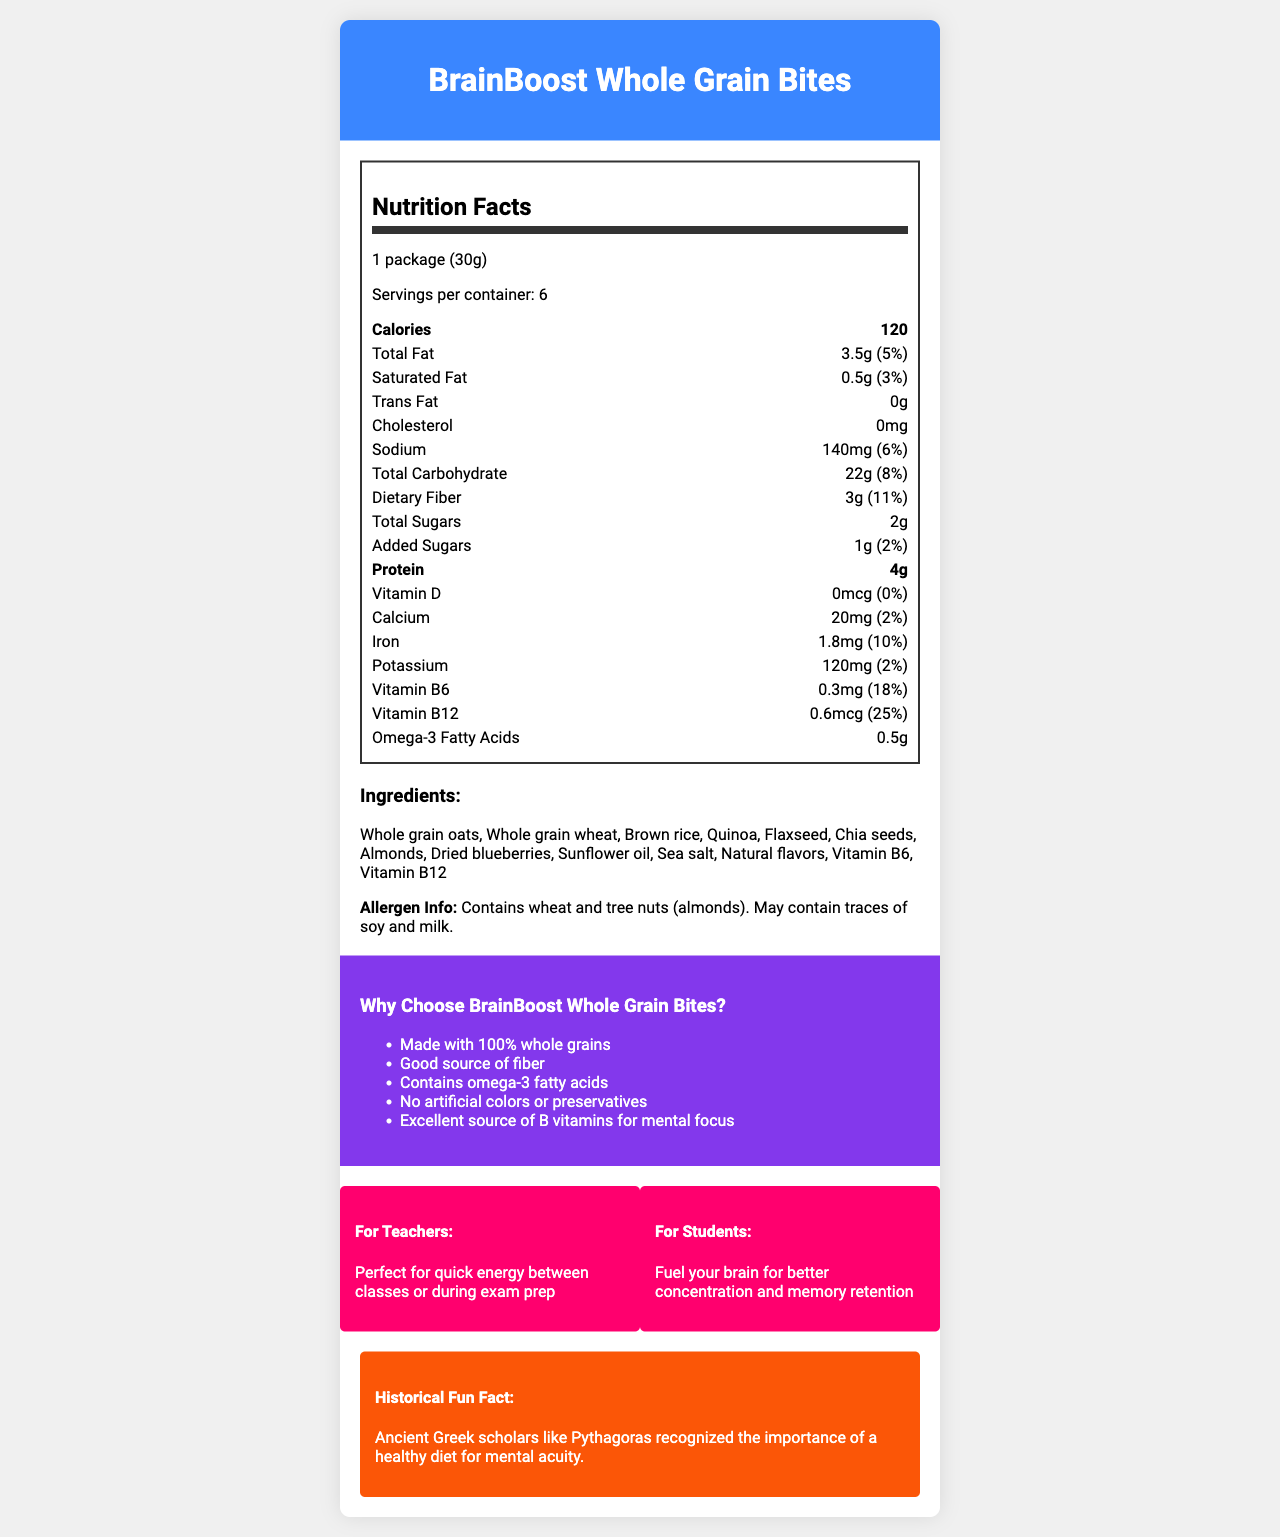how many calories are in one serving? The document states that one serving contains 120 calories.
Answer: 120 what is the serving size of BrainBoost Whole Grain Bites? The document lists the serving size as 1 package (30g).
Answer: 1 package (30g) how much dietary fiber is in one serving? The nutritional information shows that there are 3 grams of dietary fiber in one serving.
Answer: 3g what percentage of the daily value of sodium does one serving provide? The document indicates that one serving provides 6% of the daily value for sodium.
Answer: 6% what allergen information is provided for BrainBoost Whole Grain Bites? The allergen info section specifies the product contains wheat and tree nuts (almonds) and may contain traces of soy and milk.
Answer: Contains wheat and tree nuts (almonds). May contain traces of soy and milk. how much Vitamin B12 is in one serving? The nutrition label shows that there are 0.6mcg of Vitamin B12 in one serving, providing 25% of the daily value.
Answer: 0.6mcg (25%) what are the total carbohydrates and the associated daily value percentage in one serving? The document lists 22 grams of total carbohydrates, which is 8% of the daily value.
Answer: 22g (8%) which is not an ingredient in BrainBoost Whole Grain Bites? A. Blueberries B. Almonds C. Honey D. Flaxseed The ingredient list includes dried blueberries, almonds, and flaxseed, but honey is not mentioned.
Answer: C what is the main purpose of BrainBoost Whole Grain Bites for teachers? A. Providing extra protein B. Quick energy between classes C. Boosting immune system D. Increasing calcium intake The document expresses that the snack is perfect for providing quick energy between classes for teachers.
Answer: B does this product contain trans fat? The nutrition facts state that the product contains 0g of trans fat.
Answer: No does the product include artificial colors or preservatives? The marketing claims section states that the product contains no artificial colors or preservatives.
Answer: No summarize the key appeals of BrainBoost Whole Grain Bites for both teachers and students. The document emphasizes that the snack is nutritious with whole grains and B vitamins for mental focus. It's ideal for quick energy for teachers and enhancing concentration for students.
Answer: BrainBoost Whole Grain Bites provide a nutritious snack option rich in whole grains, fiber, omega-3 fatty acids, and B vitamins to promote mental focus and quick energy between classes for teachers and better concentration and memory retention for students. what is the historical fun fact mentioned in the document? The document includes a historical fun fact about Ancient Greek scholars recognizing the importance of a healthy diet for mental sharpness.
Answer: Ancient Greek scholars like Pythagoras recognized the importance of a healthy diet for mental acuity. what is the production date of BrainBoost Whole Grain Bites? The document does not provide any information related to the production date.
Answer: Cannot be determined 